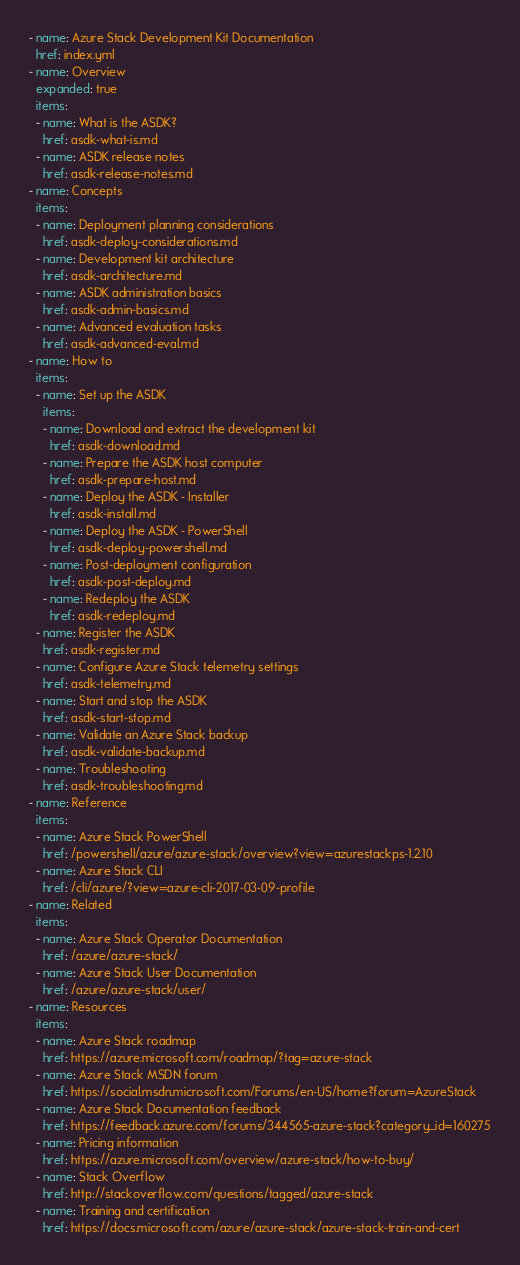Convert code to text. <code><loc_0><loc_0><loc_500><loc_500><_YAML_>- name: Azure Stack Development Kit Documentation
  href: index.yml
- name: Overview
  expanded: true
  items:
  - name: What is the ASDK?
    href: asdk-what-is.md
  - name: ASDK release notes
    href: asdk-release-notes.md
- name: Concepts
  items:
  - name: Deployment planning considerations
    href: asdk-deploy-considerations.md
  - name: Development kit architecture
    href: asdk-architecture.md
  - name: ASDK administration basics
    href: asdk-admin-basics.md
  - name: Advanced evaluation tasks
    href: asdk-advanced-eval.md
- name: How to
  items:
  - name: Set up the ASDK
    items:
    - name: Download and extract the development kit
      href: asdk-download.md
    - name: Prepare the ASDK host computer
      href: asdk-prepare-host.md
    - name: Deploy the ASDK - Installer
      href: asdk-install.md
    - name: Deploy the ASDK - PowerShell
      href: asdk-deploy-powershell.md
    - name: Post-deployment configuration
      href: asdk-post-deploy.md
    - name: Redeploy the ASDK
      href: asdk-redeploy.md 
  - name: Register the ASDK
    href: asdk-register.md
  - name: Configure Azure Stack telemetry settings
    href: asdk-telemetry.md  
  - name: Start and stop the ASDK
    href: asdk-start-stop.md
  - name: Validate an Azure Stack backup
    href: asdk-validate-backup.md
  - name: Troubleshooting
    href: asdk-troubleshooting.md
- name: Reference
  items:
  - name: Azure Stack PowerShell
    href: /powershell/azure/azure-stack/overview?view=azurestackps-1.2.10
  - name: Azure Stack CLI
    href: /cli/azure/?view=azure-cli-2017-03-09-profile
- name: Related
  items:
  - name: Azure Stack Operator Documentation
    href: /azure/azure-stack/
  - name: Azure Stack User Documentation
    href: /azure/azure-stack/user/
- name: Resources
  items:
  - name: Azure Stack roadmap
    href: https://azure.microsoft.com/roadmap/?tag=azure-stack
  - name: Azure Stack MSDN forum
    href: https://social.msdn.microsoft.com/Forums/en-US/home?forum=AzureStack
  - name: Azure Stack Documentation feedback
    href: https://feedback.azure.com/forums/344565-azure-stack?category_id=160275
  - name: Pricing information
    href: https://azure.microsoft.com/overview/azure-stack/how-to-buy/
  - name: Stack Overflow
    href: http://stackoverflow.com/questions/tagged/azure-stack
  - name: Training and certification
    href: https://docs.microsoft.com/azure/azure-stack/azure-stack-train-and-cert
</code> 